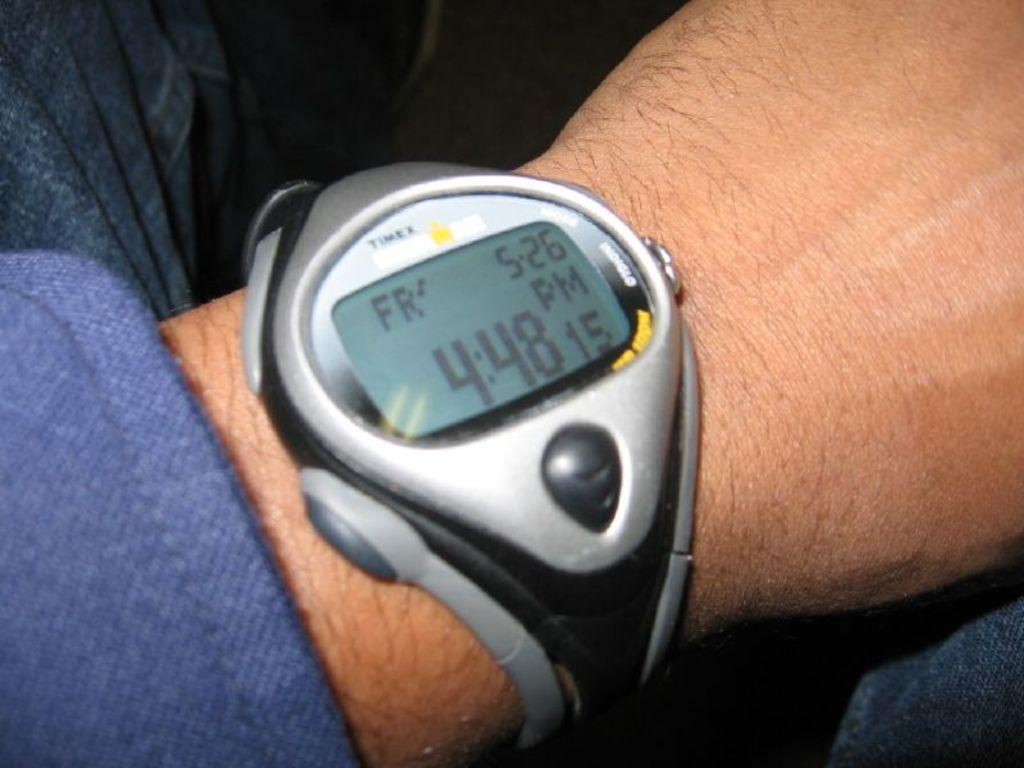Provide a one-sentence caption for the provided image. A person wearing a Timex digital watch showing 4:48 as the time. 